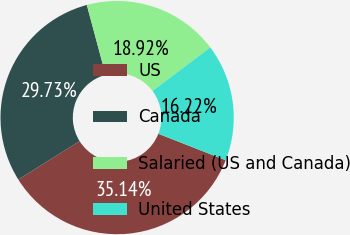Convert chart. <chart><loc_0><loc_0><loc_500><loc_500><pie_chart><fcel>US<fcel>Canada<fcel>Salaried (US and Canada)<fcel>United States<nl><fcel>35.14%<fcel>29.73%<fcel>18.92%<fcel>16.22%<nl></chart> 